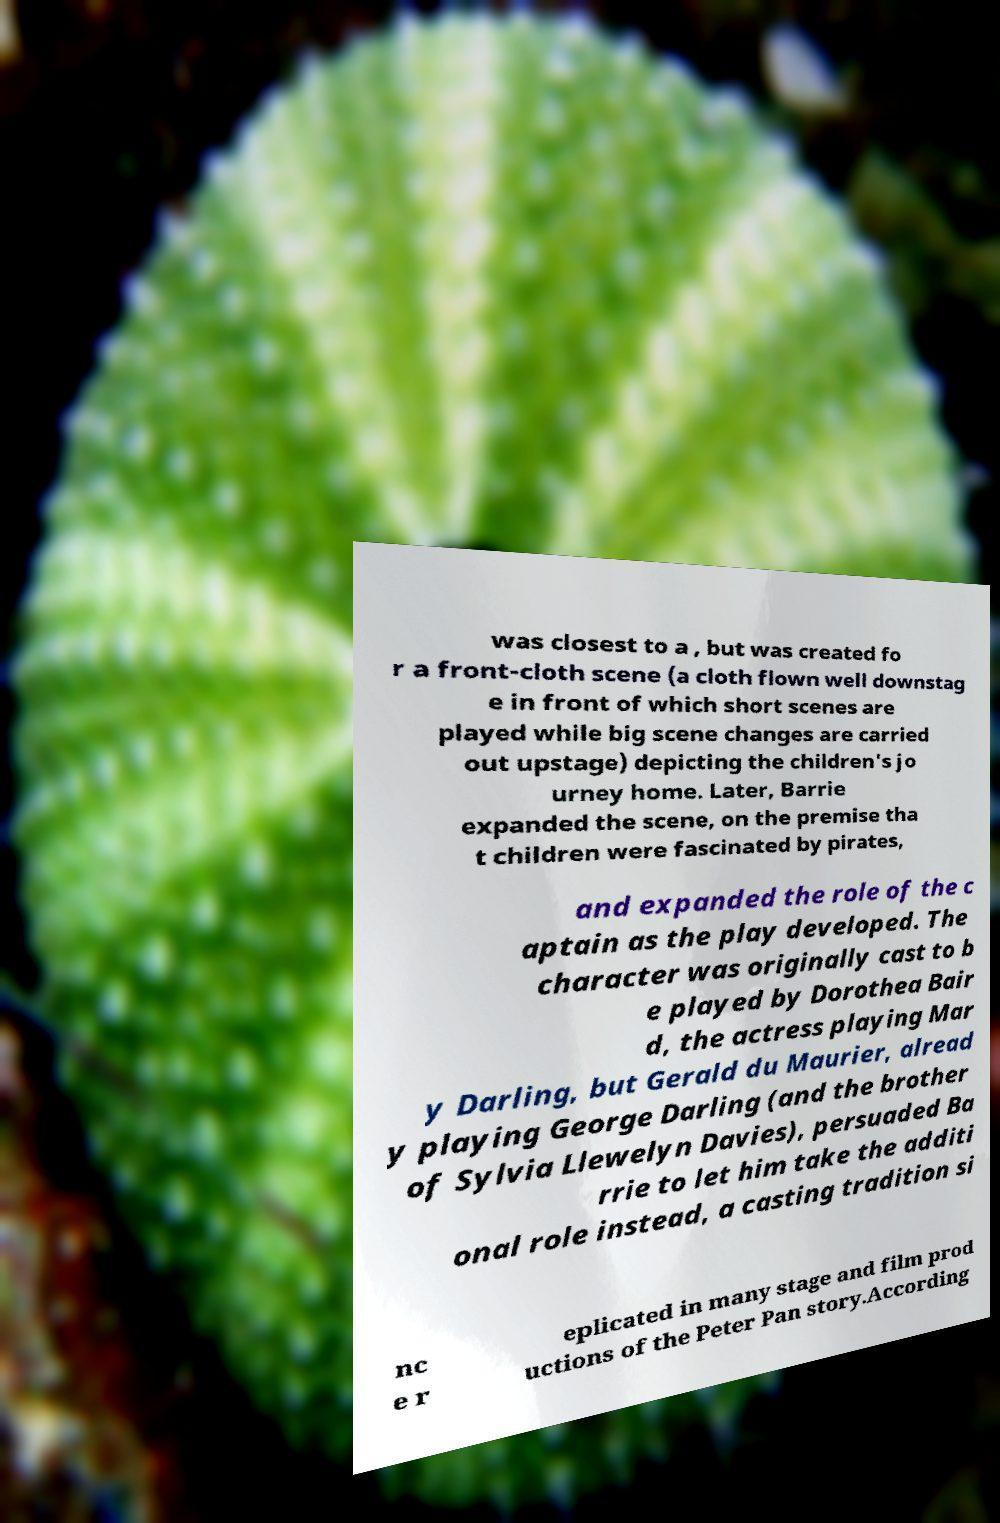What messages or text are displayed in this image? I need them in a readable, typed format. was closest to a , but was created fo r a front-cloth scene (a cloth flown well downstag e in front of which short scenes are played while big scene changes are carried out upstage) depicting the children's jo urney home. Later, Barrie expanded the scene, on the premise tha t children were fascinated by pirates, and expanded the role of the c aptain as the play developed. The character was originally cast to b e played by Dorothea Bair d, the actress playing Mar y Darling, but Gerald du Maurier, alread y playing George Darling (and the brother of Sylvia Llewelyn Davies), persuaded Ba rrie to let him take the additi onal role instead, a casting tradition si nc e r eplicated in many stage and film prod uctions of the Peter Pan story.According 